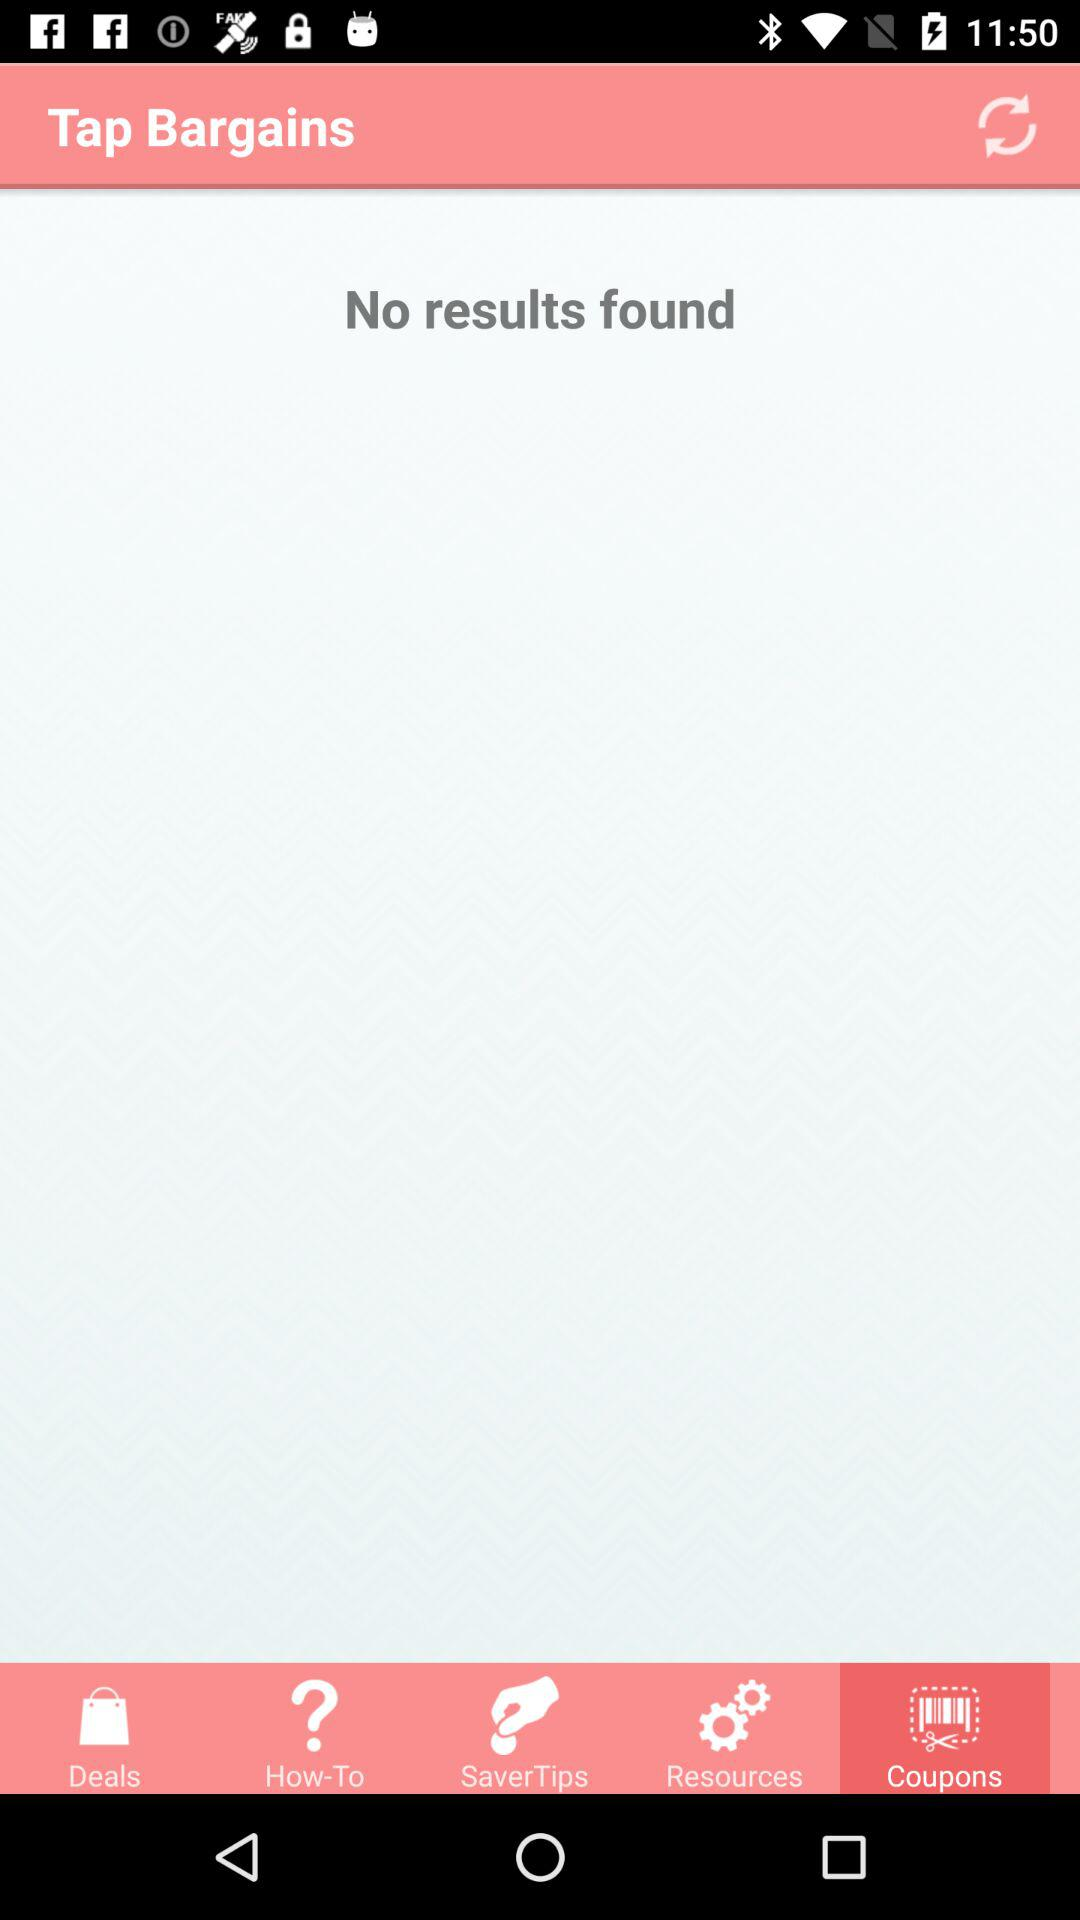Which tab is selected? The selected tab is "Coupons". 